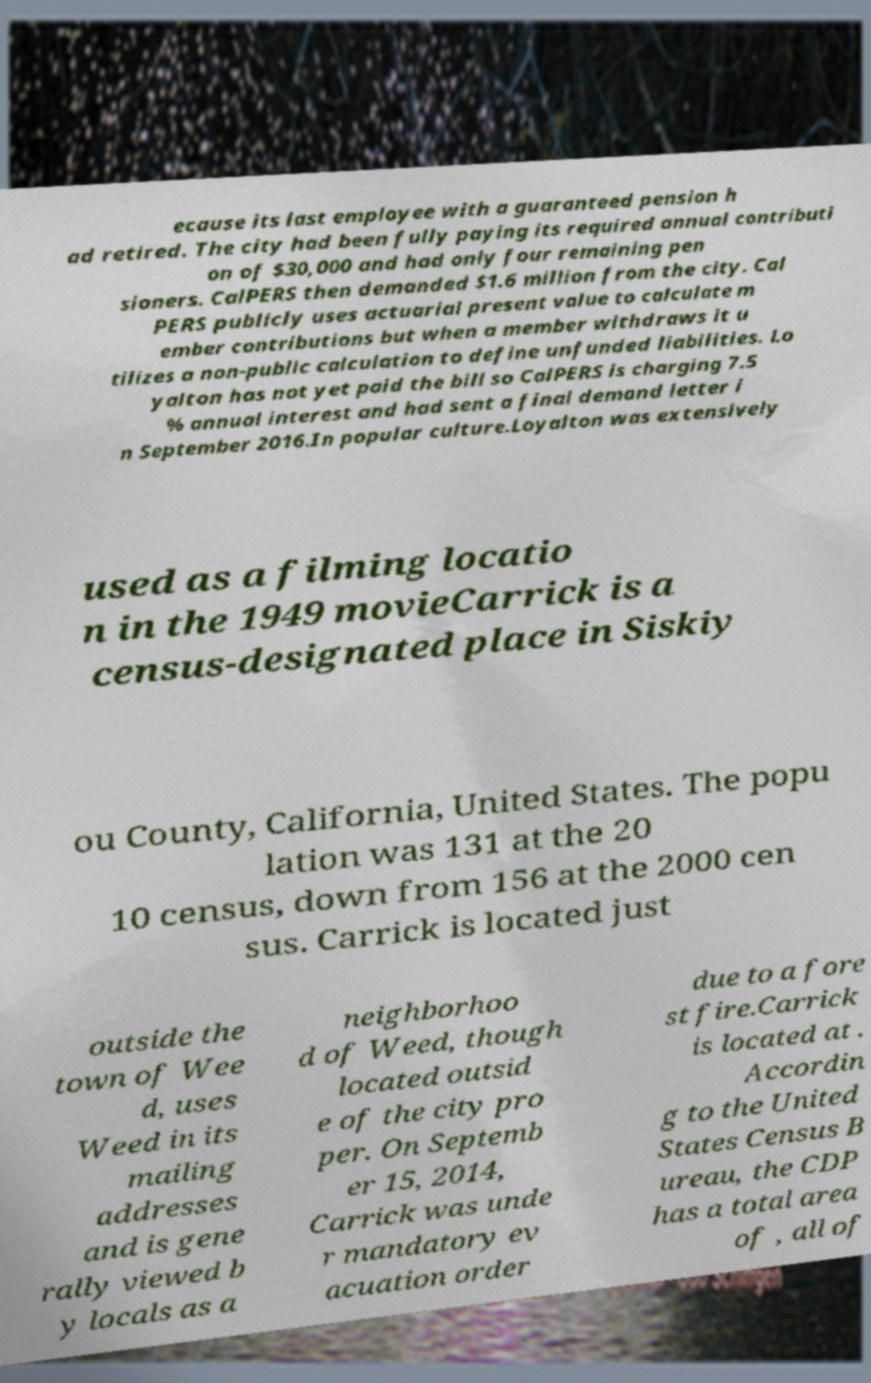Please read and relay the text visible in this image. What does it say? ecause its last employee with a guaranteed pension h ad retired. The city had been fully paying its required annual contributi on of $30,000 and had only four remaining pen sioners. CalPERS then demanded $1.6 million from the city. Cal PERS publicly uses actuarial present value to calculate m ember contributions but when a member withdraws it u tilizes a non-public calculation to define unfunded liabilities. Lo yalton has not yet paid the bill so CalPERS is charging 7.5 % annual interest and had sent a final demand letter i n September 2016.In popular culture.Loyalton was extensively used as a filming locatio n in the 1949 movieCarrick is a census-designated place in Siskiy ou County, California, United States. The popu lation was 131 at the 20 10 census, down from 156 at the 2000 cen sus. Carrick is located just outside the town of Wee d, uses Weed in its mailing addresses and is gene rally viewed b y locals as a neighborhoo d of Weed, though located outsid e of the city pro per. On Septemb er 15, 2014, Carrick was unde r mandatory ev acuation order due to a fore st fire.Carrick is located at . Accordin g to the United States Census B ureau, the CDP has a total area of , all of 